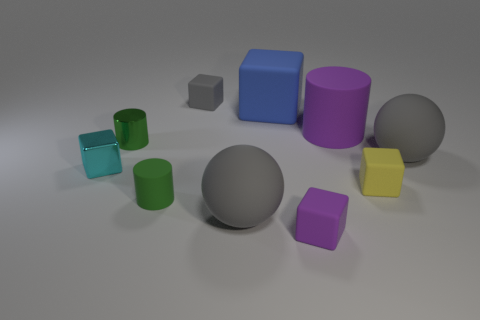How might these objects be used in an educational setting? These objects could serve as valuable tools in an educational setting for a variety of lessons. They could be used to teach children about geometry by discussing the different shapes and their properties. They can also be useful for a color lesson, where children learn to identify and name colors. Furthermore, they could be used in a physics class to discuss principles of volume and surface area, or in an art class to explore the concept of still life arrangement and drawing perspective. 